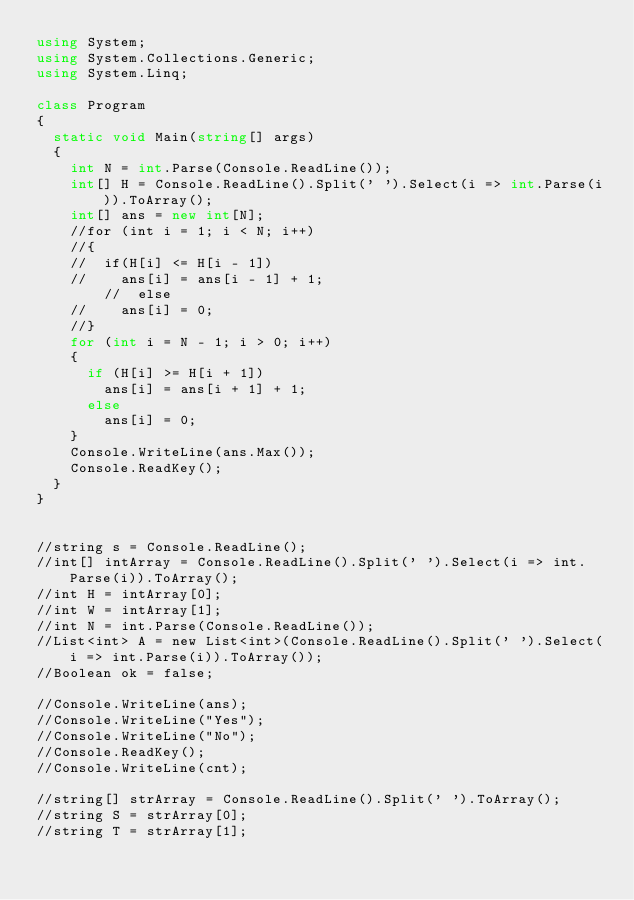<code> <loc_0><loc_0><loc_500><loc_500><_C#_>using System;
using System.Collections.Generic;
using System.Linq;

class Program
{
	static void Main(string[] args)
	{
		int N = int.Parse(Console.ReadLine());
		int[] H = Console.ReadLine().Split(' ').Select(i => int.Parse(i)).ToArray();
		int[] ans = new int[N];
		//for (int i = 1; i < N; i++)
		//{
		//	if(H[i] <= H[i - 1])
		//		ans[i] = ans[i - 1] + 1;
        //  else
		//		ans[i] = 0;
		//}
		for (int i = N - 1; i > 0; i++)
		{
			if (H[i] >= H[i + 1])
				ans[i] = ans[i + 1] + 1;
			else
				ans[i] = 0;
		}
		Console.WriteLine(ans.Max());
		Console.ReadKey();
	}
}


//string s = Console.ReadLine();
//int[] intArray = Console.ReadLine().Split(' ').Select(i => int.Parse(i)).ToArray();
//int H = intArray[0];
//int W = intArray[1];
//int N = int.Parse(Console.ReadLine());
//List<int> A = new List<int>(Console.ReadLine().Split(' ').Select(i => int.Parse(i)).ToArray());
//Boolean ok = false;

//Console.WriteLine(ans);
//Console.WriteLine("Yes");
//Console.WriteLine("No");
//Console.ReadKey();
//Console.WriteLine(cnt);

//string[] strArray = Console.ReadLine().Split(' ').ToArray();
//string S = strArray[0];
//string T = strArray[1];
</code> 